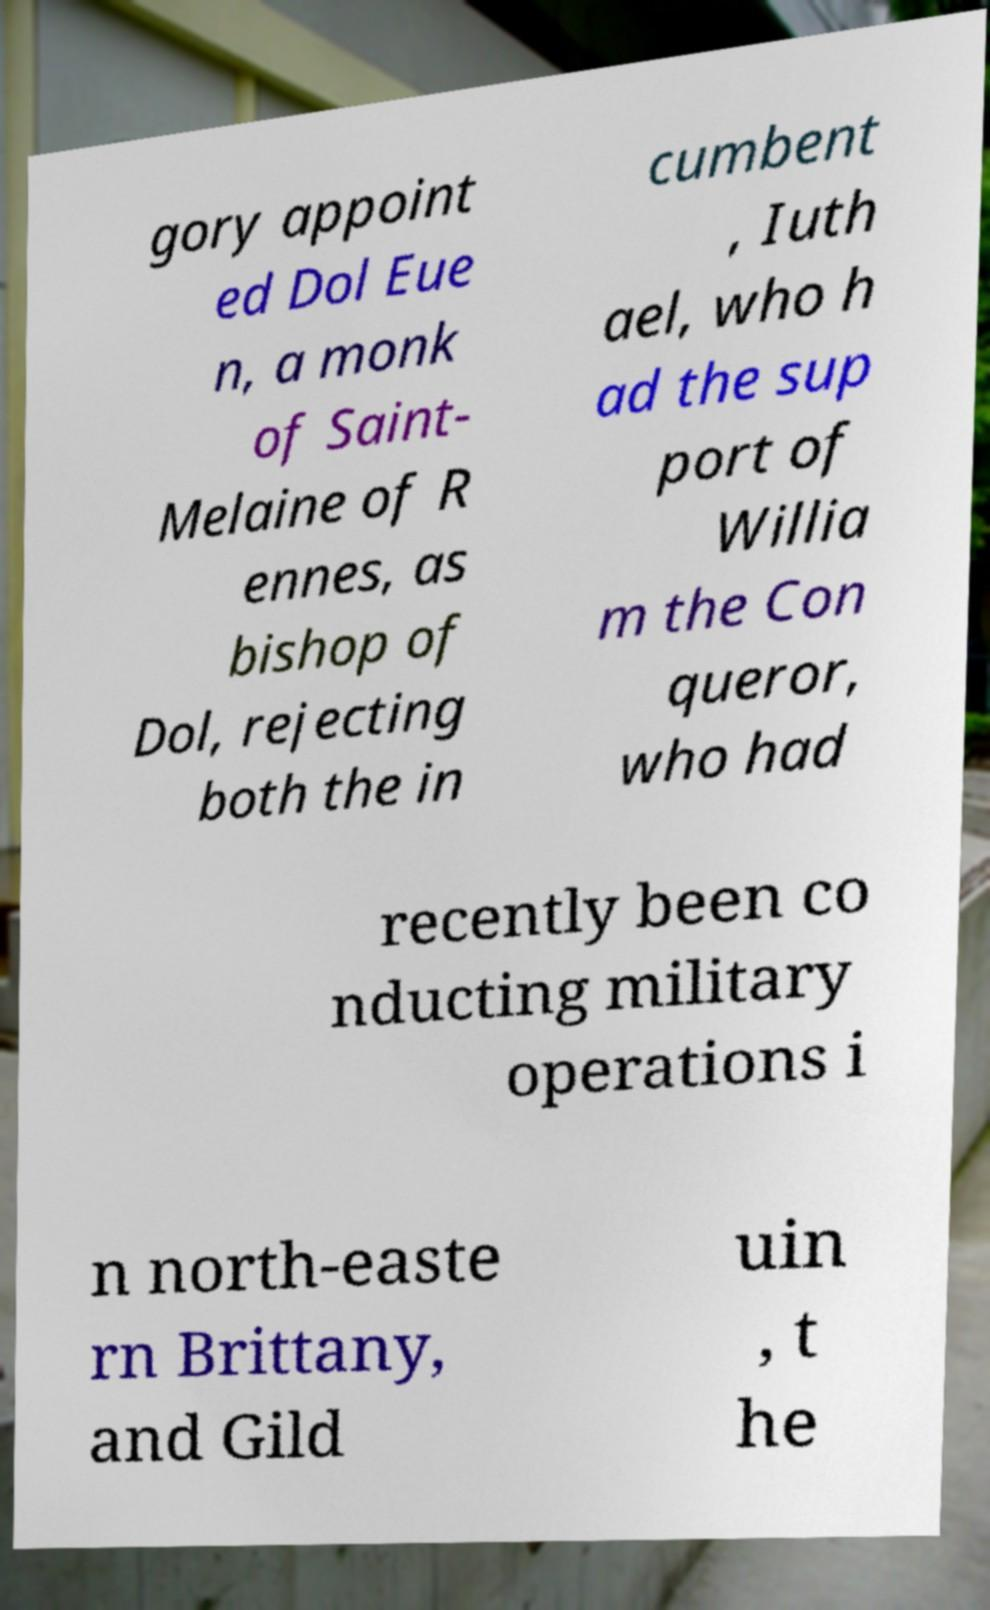I need the written content from this picture converted into text. Can you do that? gory appoint ed Dol Eue n, a monk of Saint- Melaine of R ennes, as bishop of Dol, rejecting both the in cumbent , Iuth ael, who h ad the sup port of Willia m the Con queror, who had recently been co nducting military operations i n north-easte rn Brittany, and Gild uin , t he 